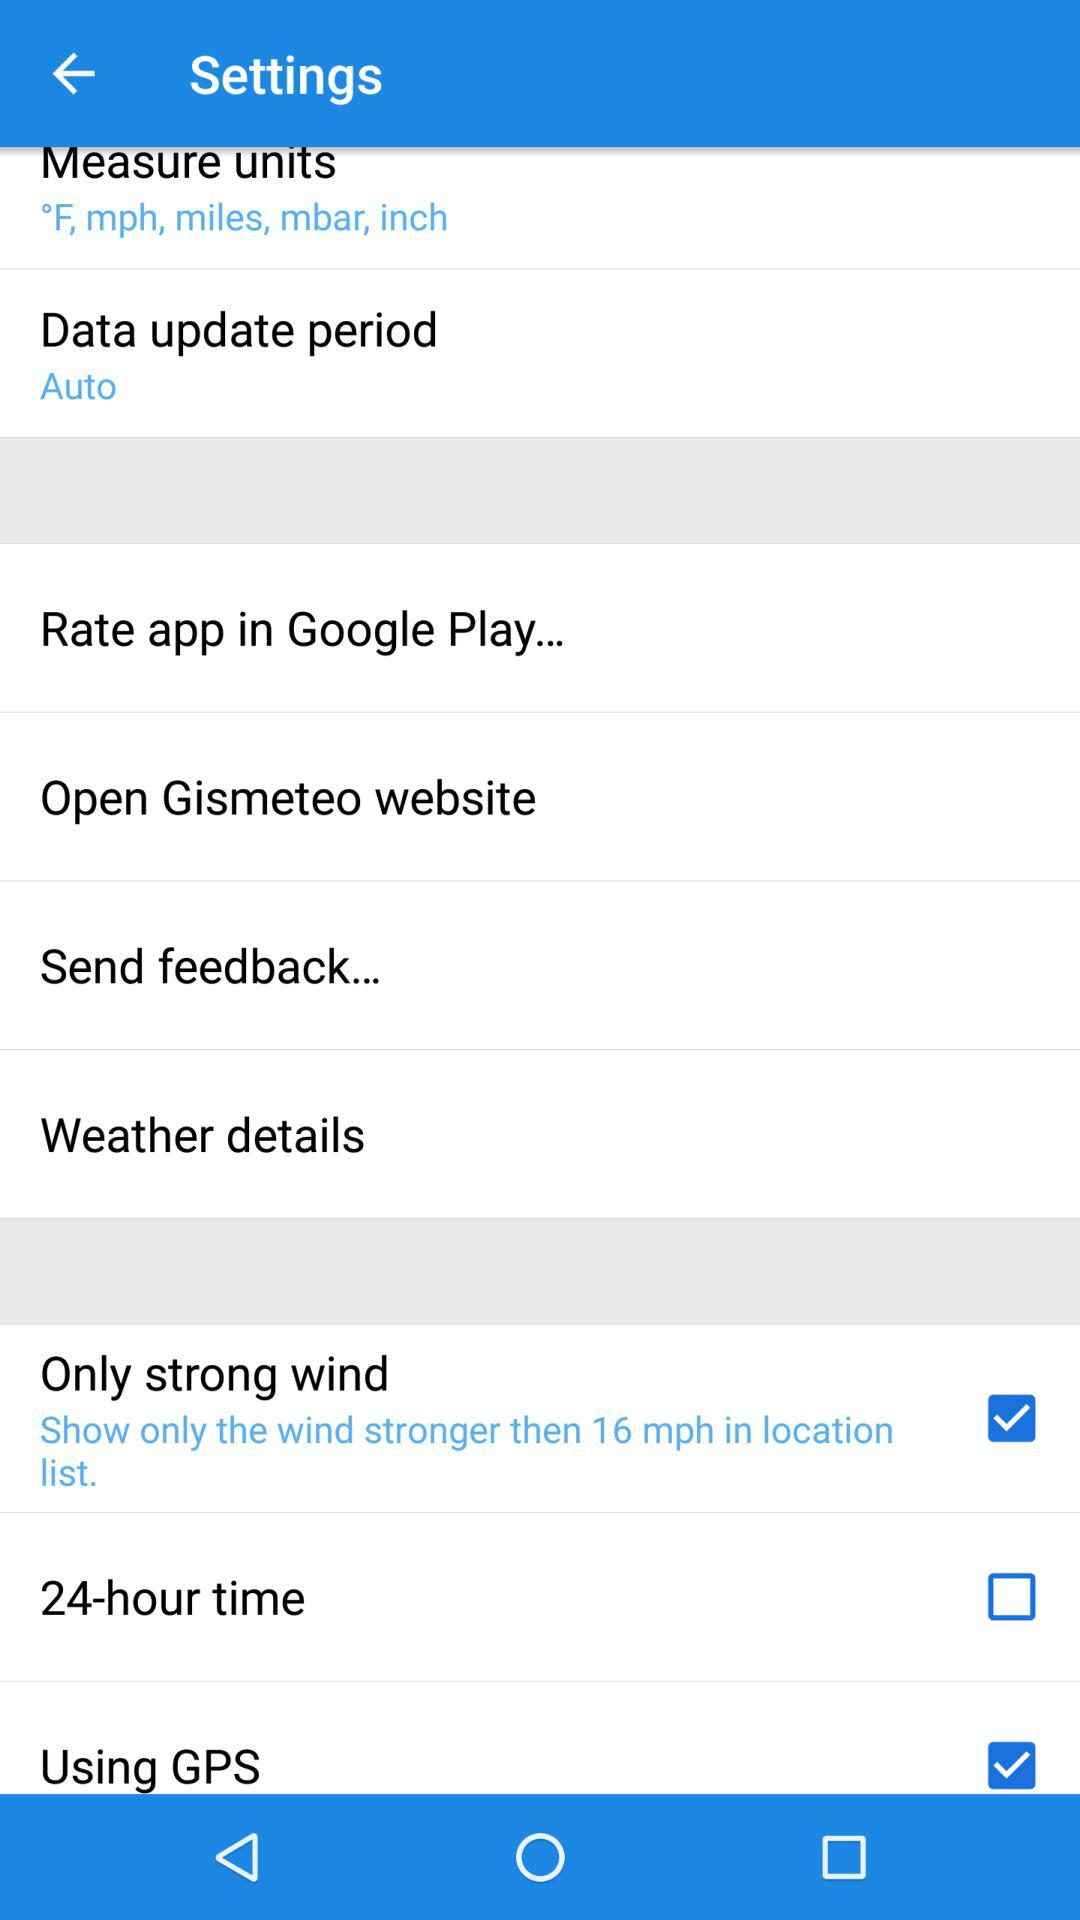What is the data update period? The data update period is "Auto". 